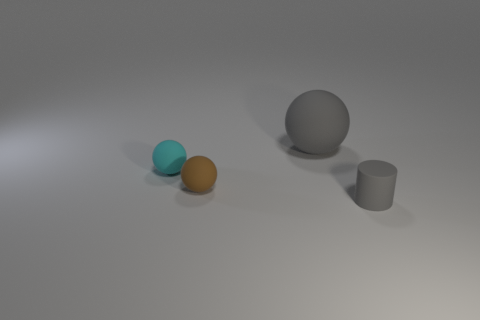Add 3 brown rubber cubes. How many objects exist? 7 Subtract all cylinders. How many objects are left? 3 Subtract all gray spheres. Subtract all tiny matte cylinders. How many objects are left? 2 Add 1 gray balls. How many gray balls are left? 2 Add 2 gray rubber objects. How many gray rubber objects exist? 4 Subtract 0 red blocks. How many objects are left? 4 